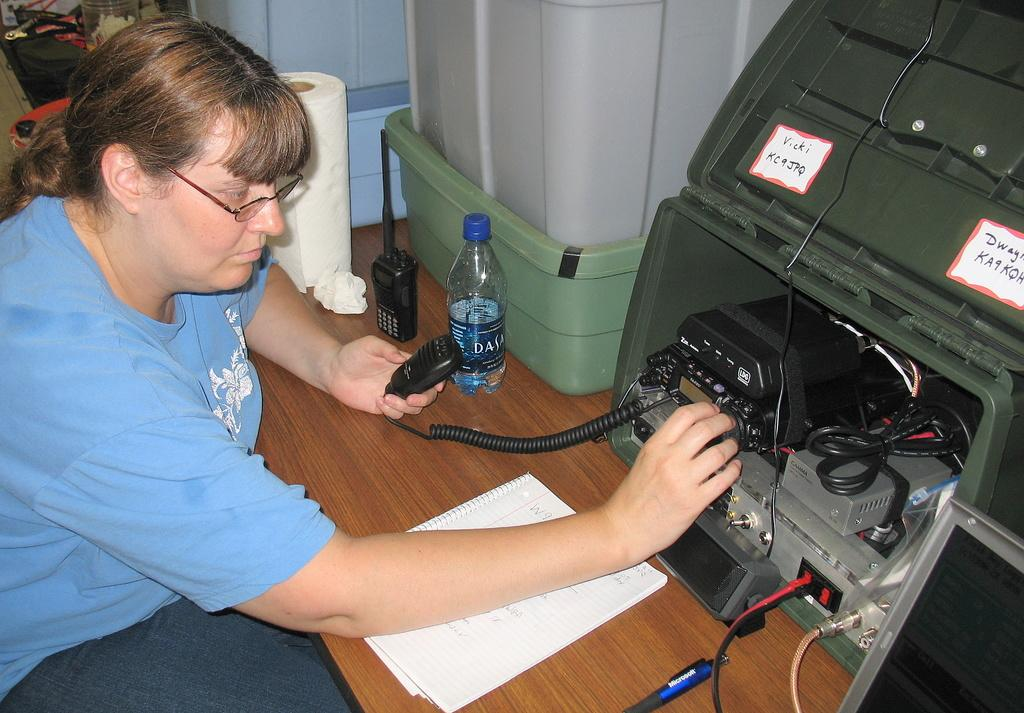<image>
Describe the image concisely. A woman wearing a blue shirt working on an electronic next to a bottle of Dasani water. 